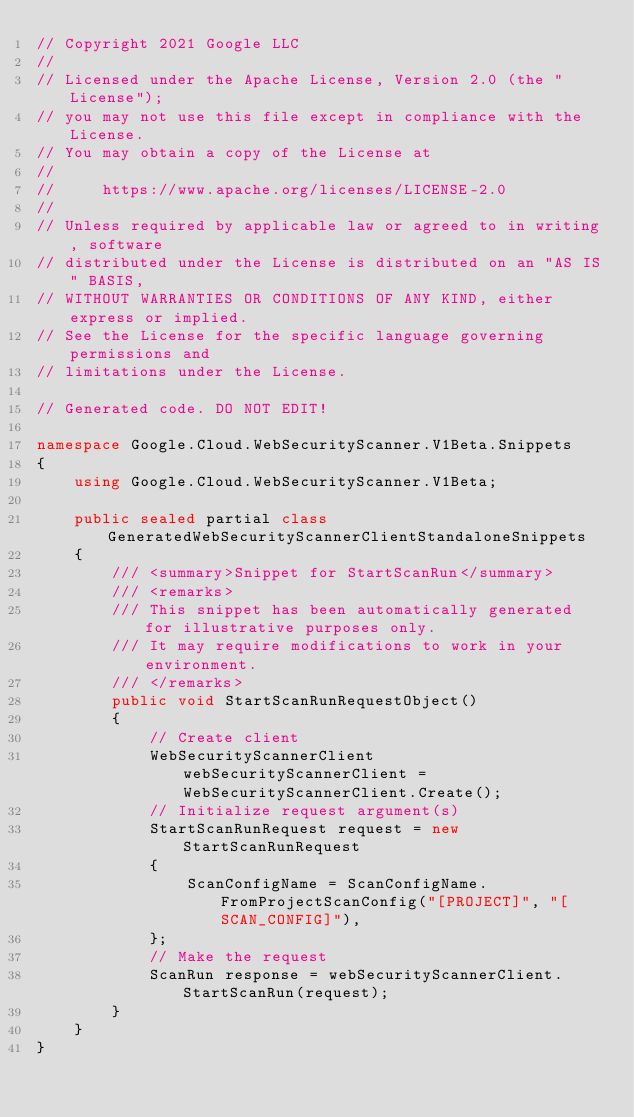<code> <loc_0><loc_0><loc_500><loc_500><_C#_>// Copyright 2021 Google LLC
//
// Licensed under the Apache License, Version 2.0 (the "License");
// you may not use this file except in compliance with the License.
// You may obtain a copy of the License at
//
//     https://www.apache.org/licenses/LICENSE-2.0
//
// Unless required by applicable law or agreed to in writing, software
// distributed under the License is distributed on an "AS IS" BASIS,
// WITHOUT WARRANTIES OR CONDITIONS OF ANY KIND, either express or implied.
// See the License for the specific language governing permissions and
// limitations under the License.

// Generated code. DO NOT EDIT!

namespace Google.Cloud.WebSecurityScanner.V1Beta.Snippets
{
    using Google.Cloud.WebSecurityScanner.V1Beta;

    public sealed partial class GeneratedWebSecurityScannerClientStandaloneSnippets
    {
        /// <summary>Snippet for StartScanRun</summary>
        /// <remarks>
        /// This snippet has been automatically generated for illustrative purposes only.
        /// It may require modifications to work in your environment.
        /// </remarks>
        public void StartScanRunRequestObject()
        {
            // Create client
            WebSecurityScannerClient webSecurityScannerClient = WebSecurityScannerClient.Create();
            // Initialize request argument(s)
            StartScanRunRequest request = new StartScanRunRequest
            {
                ScanConfigName = ScanConfigName.FromProjectScanConfig("[PROJECT]", "[SCAN_CONFIG]"),
            };
            // Make the request
            ScanRun response = webSecurityScannerClient.StartScanRun(request);
        }
    }
}
</code> 